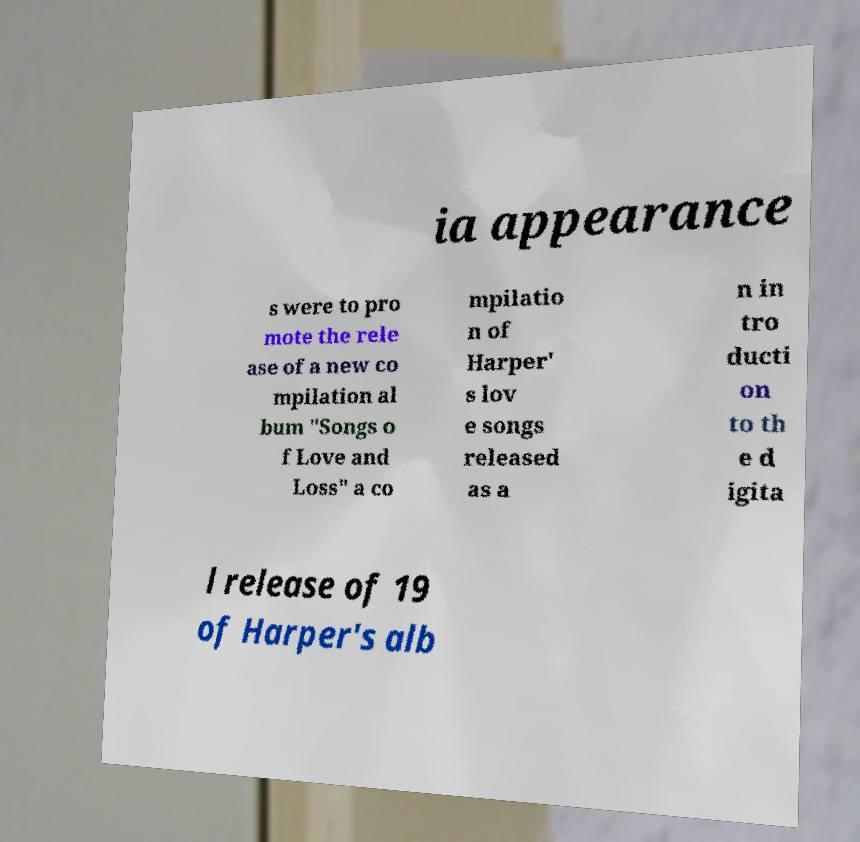Could you extract and type out the text from this image? ia appearance s were to pro mote the rele ase of a new co mpilation al bum "Songs o f Love and Loss" a co mpilatio n of Harper' s lov e songs released as a n in tro ducti on to th e d igita l release of 19 of Harper's alb 